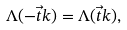<formula> <loc_0><loc_0><loc_500><loc_500>\Lambda ( - \vec { t } k ) = \Lambda ( \vec { t } k ) ,</formula> 